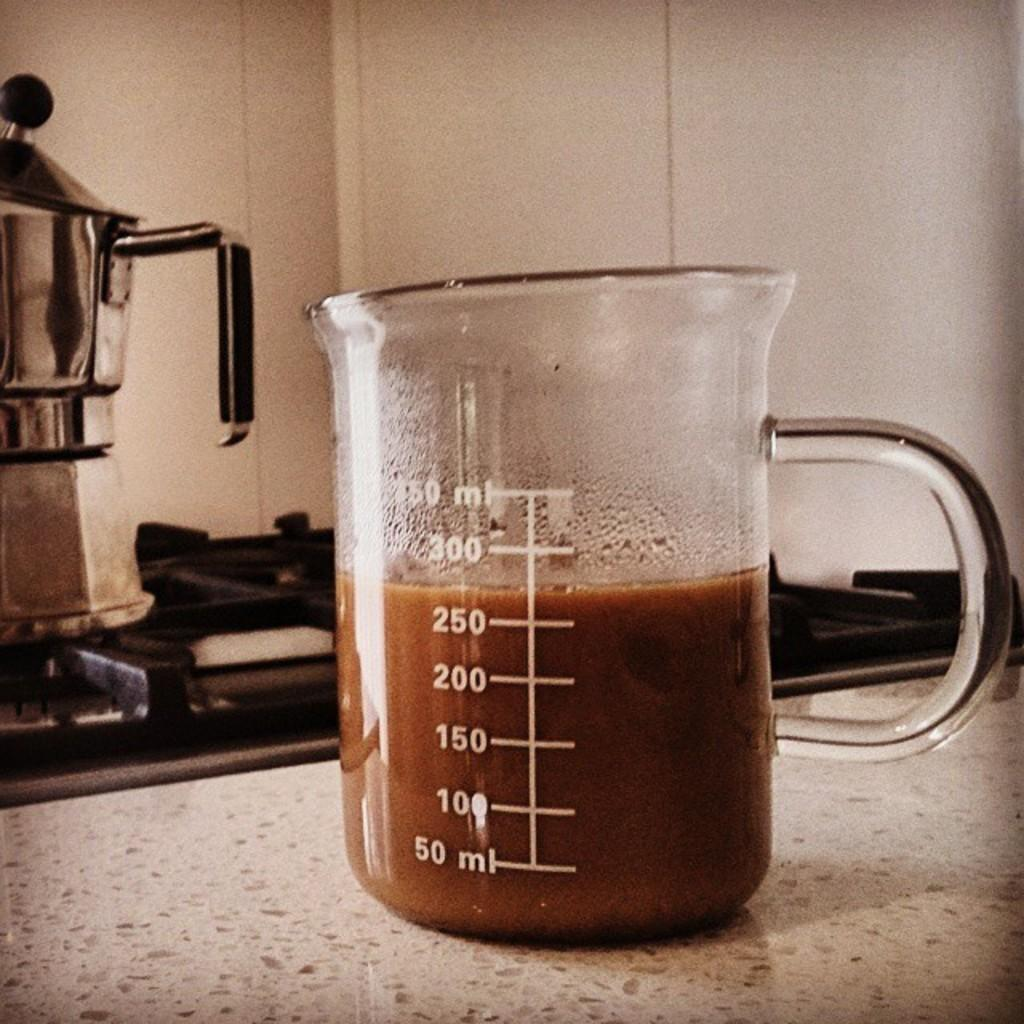What is there is a beaker mug with a drink in the image, what is the drink? The facts do not specify the type of drink in the beaker mug. Where is the beaker mug located in the image? The beaker mug is on a platform. What can be seen in the background of the image? There is a gas stove, a bowl, and a wall in the background of the image. What type of peace symbol is depicted on the wall in the image? There is no peace symbol present on the wall in the image. How many tomatoes are visible in the bowl in the background of the image? There is no mention of tomatoes in the image; the bowl in the background is not specified to contain any particular item. 